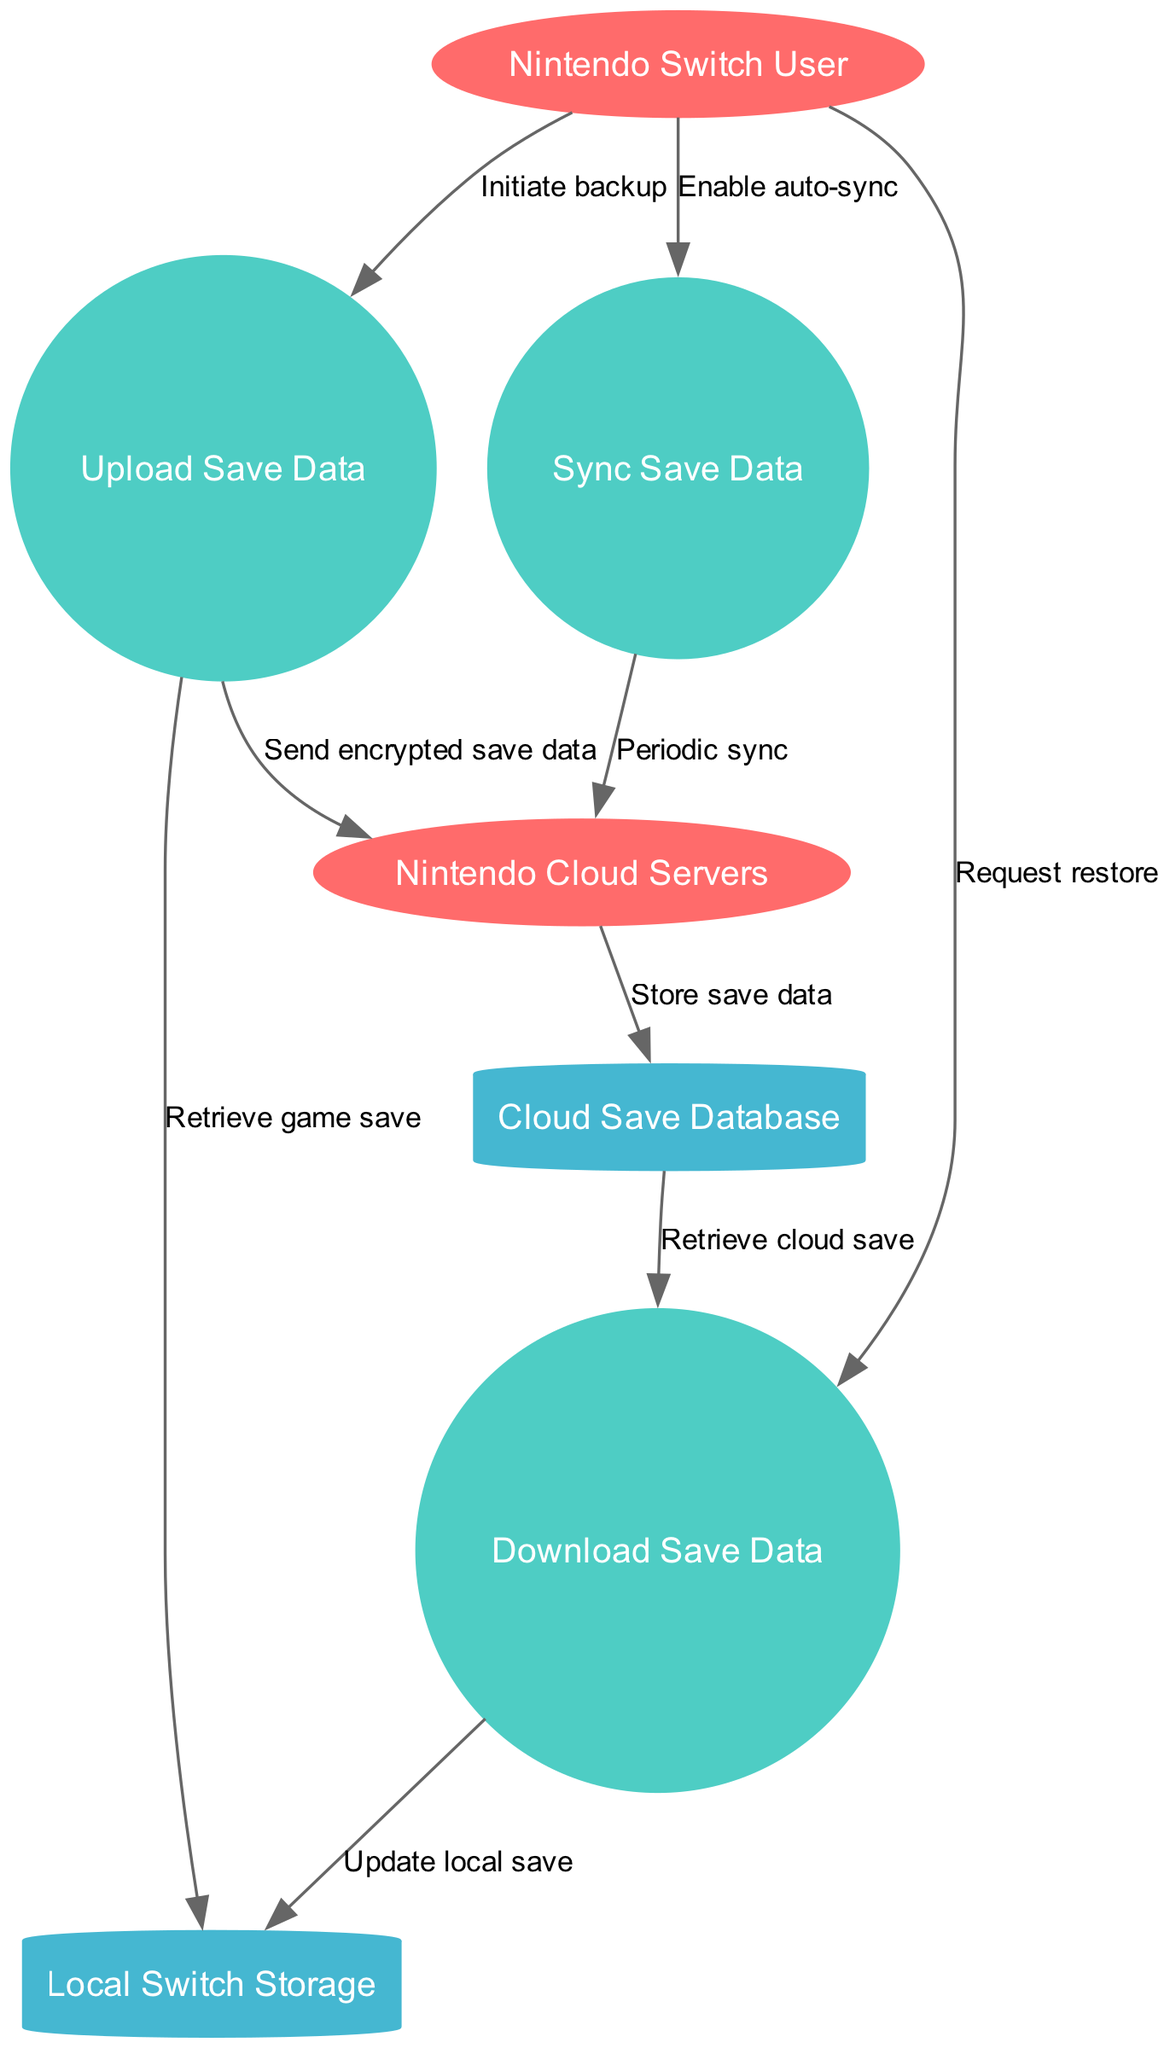What are the external entities in the diagram? The diagram includes two external entities: "Nintendo Switch User" and "Nintendo Cloud Servers." These entities represent the users and the server infrastructure respectively.
Answer: Nintendo Switch User, Nintendo Cloud Servers How many processes are represented in the diagram? There are three processes in the diagram, which are labeled as "Upload Save Data," "Download Save Data," and "Sync Save Data." Counting each distinctly gives the total number.
Answer: 3 What is the purpose of the data flow from "Upload Save Data" to "Nintendo Cloud Servers"? This data flow is labeled "Send encrypted save data," indicating that the process transmits the game save data after it has been backed up.
Answer: Send encrypted save data Which data store receives data from the "Nintendo Cloud Servers"? The "Cloud Save Database" receives data from the "Nintendo Cloud Servers," as shown by the label "Store save data" on that data flow.
Answer: Cloud Save Database What initiates the "Download Save Data" process? The "Download Save Data" process is initiated by the "Nintendo Switch User" who is sending the "Request restore" to download their saved data from the cloud.
Answer: Request restore What happens during the "Sync Save Data" process? The "Sync Save Data" process performs a "Periodic sync" with the "Nintendo Cloud Servers" as indicated in the data flow from the sync process to the server.
Answer: Periodic sync How does "Download Save Data" update local storage? The "Download Save Data" process updates the local storage by sending the labeled flow "Update local save" to "Local Switch Storage," indicating that local data is being refreshed based on the downloaded save.
Answer: Update local save What triggers the "Upload Save Data" process? The process is triggered by the action labeled "Initiate backup" from the "Nintendo Switch User," indicating a request to back up game saves.
Answer: Initiate backup How many data stores are present in the diagram? There are two data stores detailed in the diagram: "Local Switch Storage" and "Cloud Save Database," each serving to hold save data in different locations.
Answer: 2 